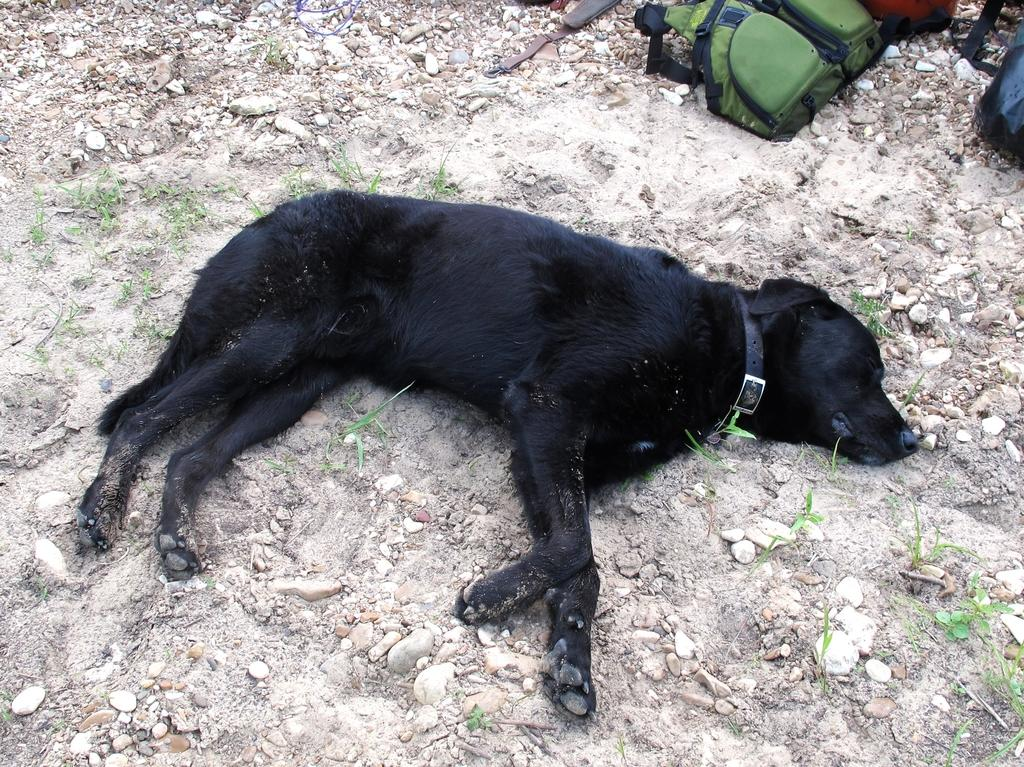What type of animal is in the image? There is a black dog in the image. Where is the dog located? The dog is laying on the sand. What other elements can be seen in the image? There are stones, grass, and objects that look like bags in the image. How many heads of lettuce can be seen in the image? There are no heads of lettuce present in the image. What type of order is being followed by the objects in the image? There is no specific order being followed by the objects in the image. 